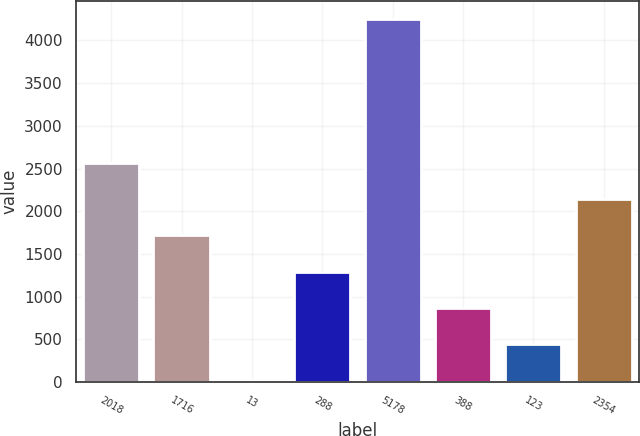Convert chart to OTSL. <chart><loc_0><loc_0><loc_500><loc_500><bar_chart><fcel>2018<fcel>1716<fcel>13<fcel>288<fcel>5178<fcel>388<fcel>123<fcel>2354<nl><fcel>2561.2<fcel>1716.8<fcel>28<fcel>1294.6<fcel>4250<fcel>872.4<fcel>450.2<fcel>2139<nl></chart> 